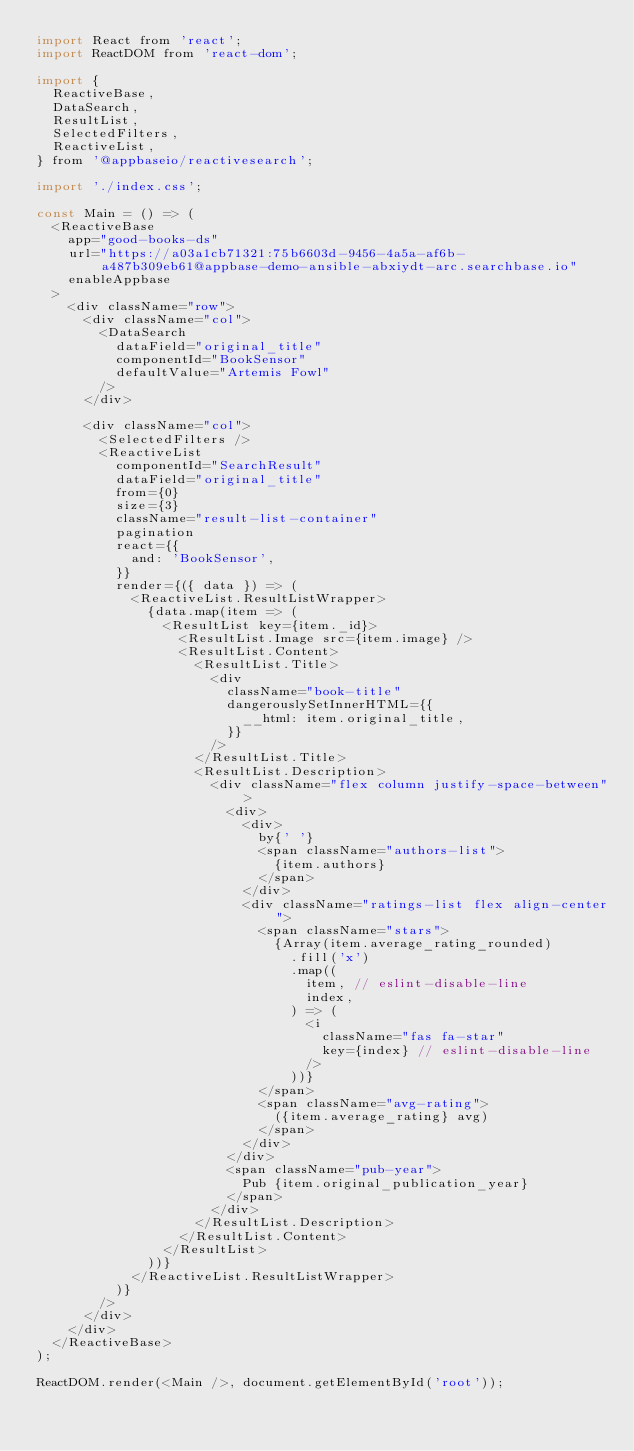<code> <loc_0><loc_0><loc_500><loc_500><_JavaScript_>import React from 'react';
import ReactDOM from 'react-dom';

import {
	ReactiveBase,
	DataSearch,
	ResultList,
	SelectedFilters,
	ReactiveList,
} from '@appbaseio/reactivesearch';

import './index.css';

const Main = () => (
	<ReactiveBase
		app="good-books-ds"
		url="https://a03a1cb71321:75b6603d-9456-4a5a-af6b-a487b309eb61@appbase-demo-ansible-abxiydt-arc.searchbase.io"
		enableAppbase
	>
		<div className="row">
			<div className="col">
				<DataSearch
					dataField="original_title"
					componentId="BookSensor"
					defaultValue="Artemis Fowl"
				/>
			</div>

			<div className="col">
				<SelectedFilters />
				<ReactiveList
					componentId="SearchResult"
					dataField="original_title"
					from={0}
					size={3}
					className="result-list-container"
					pagination
					react={{
						and: 'BookSensor',
					}}
					render={({ data }) => (
						<ReactiveList.ResultListWrapper>
							{data.map(item => (
								<ResultList key={item._id}>
									<ResultList.Image src={item.image} />
									<ResultList.Content>
										<ResultList.Title>
											<div
												className="book-title"
												dangerouslySetInnerHTML={{
													__html: item.original_title,
												}}
											/>
										</ResultList.Title>
										<ResultList.Description>
											<div className="flex column justify-space-between">
												<div>
													<div>
														by{' '}
														<span className="authors-list">
															{item.authors}
														</span>
													</div>
													<div className="ratings-list flex align-center">
														<span className="stars">
															{Array(item.average_rating_rounded)
																.fill('x')
																.map((
																	item, // eslint-disable-line
																	index,
																) => (
																	<i
																		className="fas fa-star"
																		key={index} // eslint-disable-line
																	/>
																))}
														</span>
														<span className="avg-rating">
															({item.average_rating} avg)
														</span>
													</div>
												</div>
												<span className="pub-year">
													Pub {item.original_publication_year}
												</span>
											</div>
										</ResultList.Description>
									</ResultList.Content>
								</ResultList>
							))}
						</ReactiveList.ResultListWrapper>
					)}
				/>
			</div>
		</div>
	</ReactiveBase>
);

ReactDOM.render(<Main />, document.getElementById('root'));
</code> 